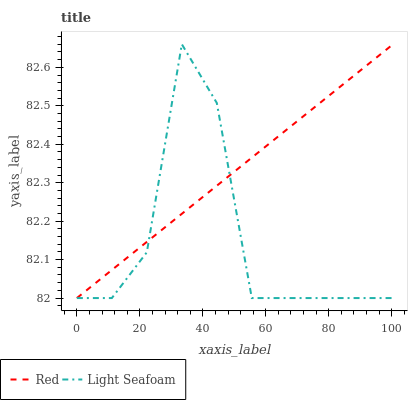Does Light Seafoam have the minimum area under the curve?
Answer yes or no. Yes. Does Red have the maximum area under the curve?
Answer yes or no. Yes. Does Red have the minimum area under the curve?
Answer yes or no. No. Is Red the smoothest?
Answer yes or no. Yes. Is Light Seafoam the roughest?
Answer yes or no. Yes. Is Red the roughest?
Answer yes or no. No. Does Light Seafoam have the lowest value?
Answer yes or no. Yes. Does Light Seafoam have the highest value?
Answer yes or no. Yes. Does Red have the highest value?
Answer yes or no. No. Does Light Seafoam intersect Red?
Answer yes or no. Yes. Is Light Seafoam less than Red?
Answer yes or no. No. Is Light Seafoam greater than Red?
Answer yes or no. No. 